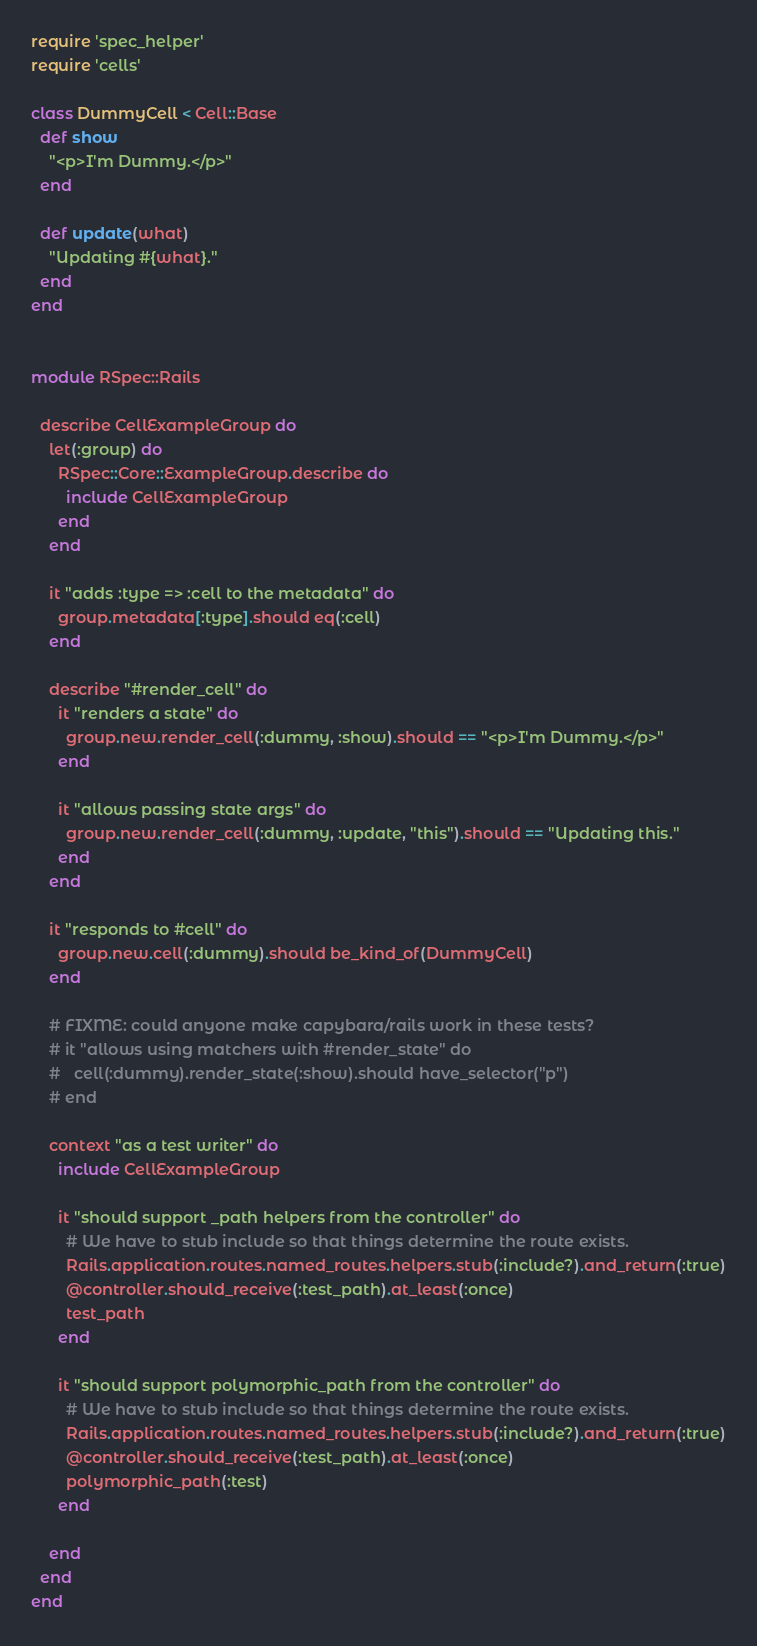<code> <loc_0><loc_0><loc_500><loc_500><_Ruby_>require 'spec_helper'
require 'cells'

class DummyCell < Cell::Base
  def show
    "<p>I'm Dummy.</p>"
  end

  def update(what)
    "Updating #{what}."
  end
end


module RSpec::Rails

  describe CellExampleGroup do
    let(:group) do
      RSpec::Core::ExampleGroup.describe do
        include CellExampleGroup
      end
    end

    it "adds :type => :cell to the metadata" do
      group.metadata[:type].should eq(:cell)
    end

    describe "#render_cell" do
      it "renders a state" do
        group.new.render_cell(:dummy, :show).should == "<p>I'm Dummy.</p>"
      end

      it "allows passing state args" do
        group.new.render_cell(:dummy, :update, "this").should == "Updating this."
      end
    end

    it "responds to #cell" do
      group.new.cell(:dummy).should be_kind_of(DummyCell)
    end

    # FIXME: could anyone make capybara/rails work in these tests?
    # it "allows using matchers with #render_state" do
    #   cell(:dummy).render_state(:show).should have_selector("p")
    # end

    context "as a test writer" do
      include CellExampleGroup

      it "should support _path helpers from the controller" do
        # We have to stub include so that things determine the route exists.
        Rails.application.routes.named_routes.helpers.stub(:include?).and_return(:true)
        @controller.should_receive(:test_path).at_least(:once)
        test_path
      end

      it "should support polymorphic_path from the controller" do
        # We have to stub include so that things determine the route exists.
        Rails.application.routes.named_routes.helpers.stub(:include?).and_return(:true)
        @controller.should_receive(:test_path).at_least(:once)
        polymorphic_path(:test)
      end

    end
  end
end
</code> 